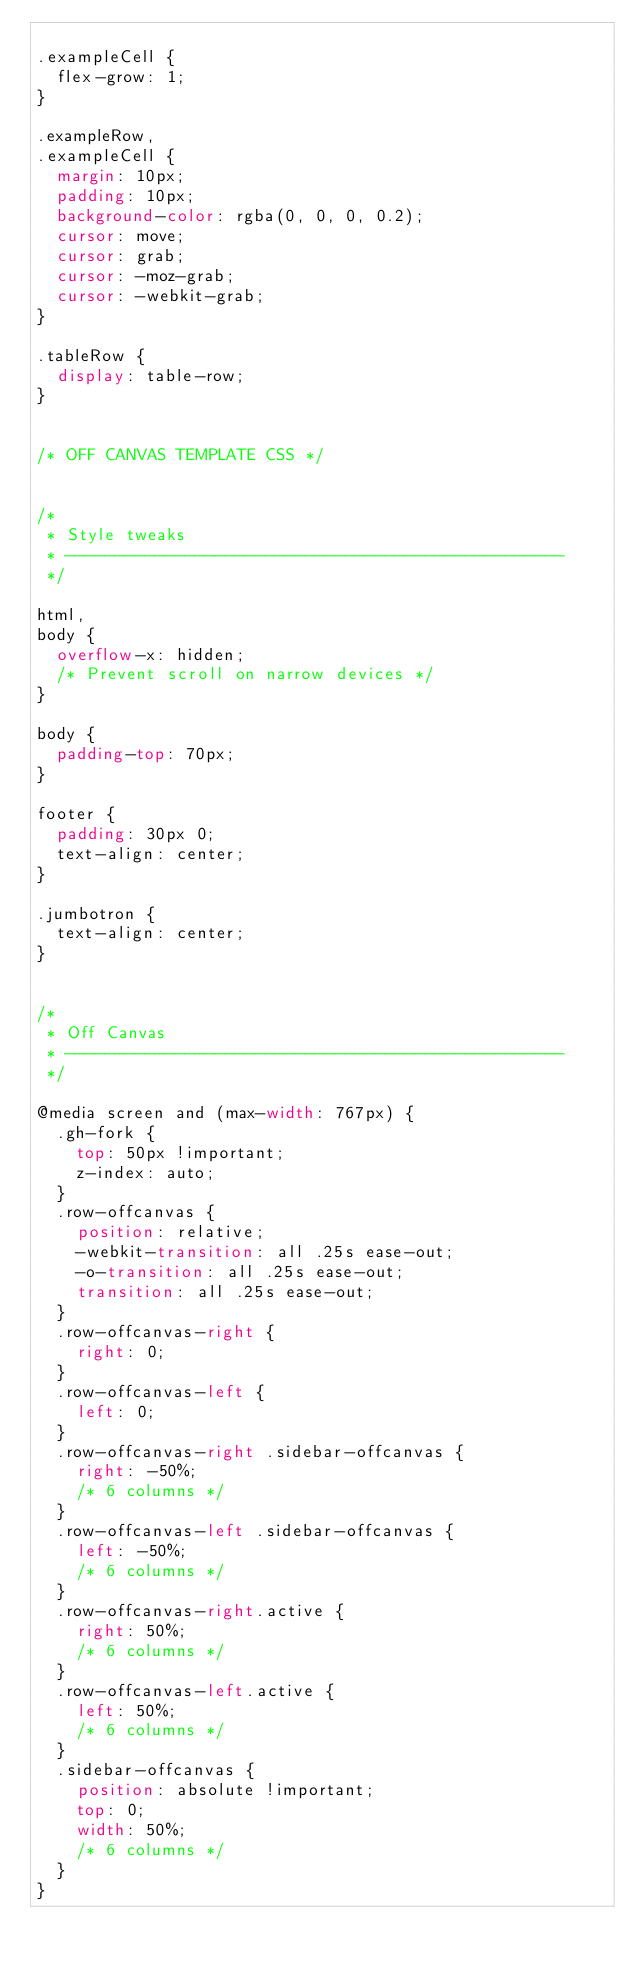Convert code to text. <code><loc_0><loc_0><loc_500><loc_500><_CSS_>
.exampleCell {
  flex-grow: 1;
}

.exampleRow,
.exampleCell {
  margin: 10px;
  padding: 10px;
  background-color: rgba(0, 0, 0, 0.2);
  cursor: move;
  cursor: grab;
  cursor: -moz-grab;
  cursor: -webkit-grab;
}

.tableRow {
  display: table-row;
}


/* OFF CANVAS TEMPLATE CSS */


/*
 * Style tweaks
 * --------------------------------------------------
 */

html,
body {
  overflow-x: hidden;
  /* Prevent scroll on narrow devices */
}

body {
  padding-top: 70px;
}

footer {
  padding: 30px 0;
  text-align: center;
}

.jumbotron {
  text-align: center;
}


/*
 * Off Canvas
 * --------------------------------------------------
 */

@media screen and (max-width: 767px) {
  .gh-fork {
    top: 50px !important;
    z-index: auto;
  }
  .row-offcanvas {
    position: relative;
    -webkit-transition: all .25s ease-out;
    -o-transition: all .25s ease-out;
    transition: all .25s ease-out;
  }
  .row-offcanvas-right {
    right: 0;
  }
  .row-offcanvas-left {
    left: 0;
  }
  .row-offcanvas-right .sidebar-offcanvas {
    right: -50%;
    /* 6 columns */
  }
  .row-offcanvas-left .sidebar-offcanvas {
    left: -50%;
    /* 6 columns */
  }
  .row-offcanvas-right.active {
    right: 50%;
    /* 6 columns */
  }
  .row-offcanvas-left.active {
    left: 50%;
    /* 6 columns */
  }
  .sidebar-offcanvas {
    position: absolute !important;
    top: 0;
    width: 50%;
    /* 6 columns */
  }
}
</code> 